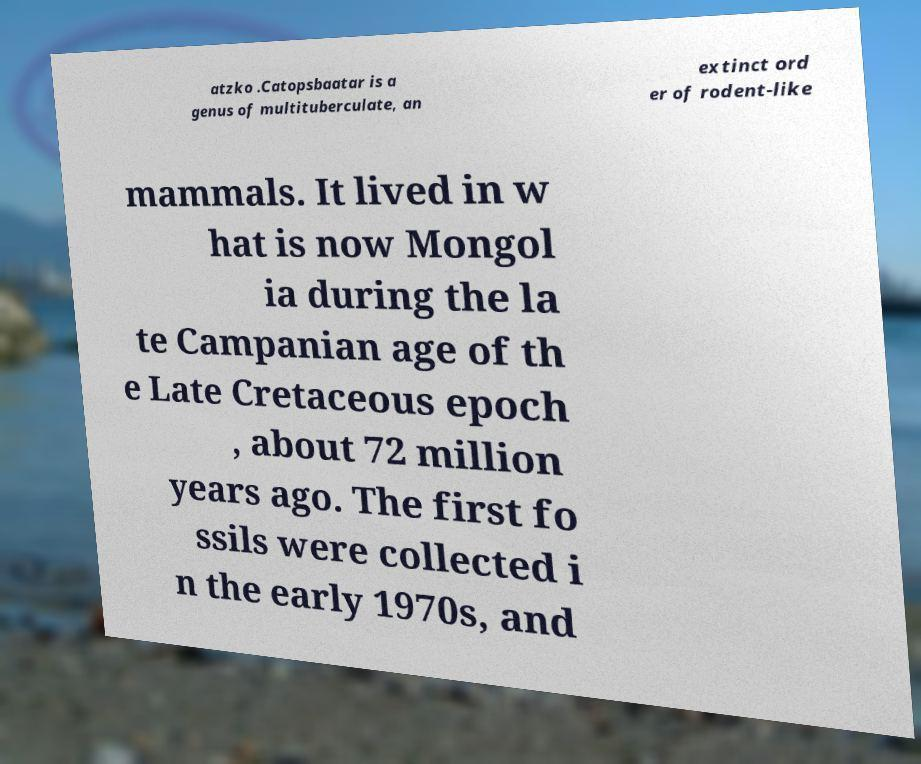Please read and relay the text visible in this image. What does it say? atzko .Catopsbaatar is a genus of multituberculate, an extinct ord er of rodent-like mammals. It lived in w hat is now Mongol ia during the la te Campanian age of th e Late Cretaceous epoch , about 72 million years ago. The first fo ssils were collected i n the early 1970s, and 